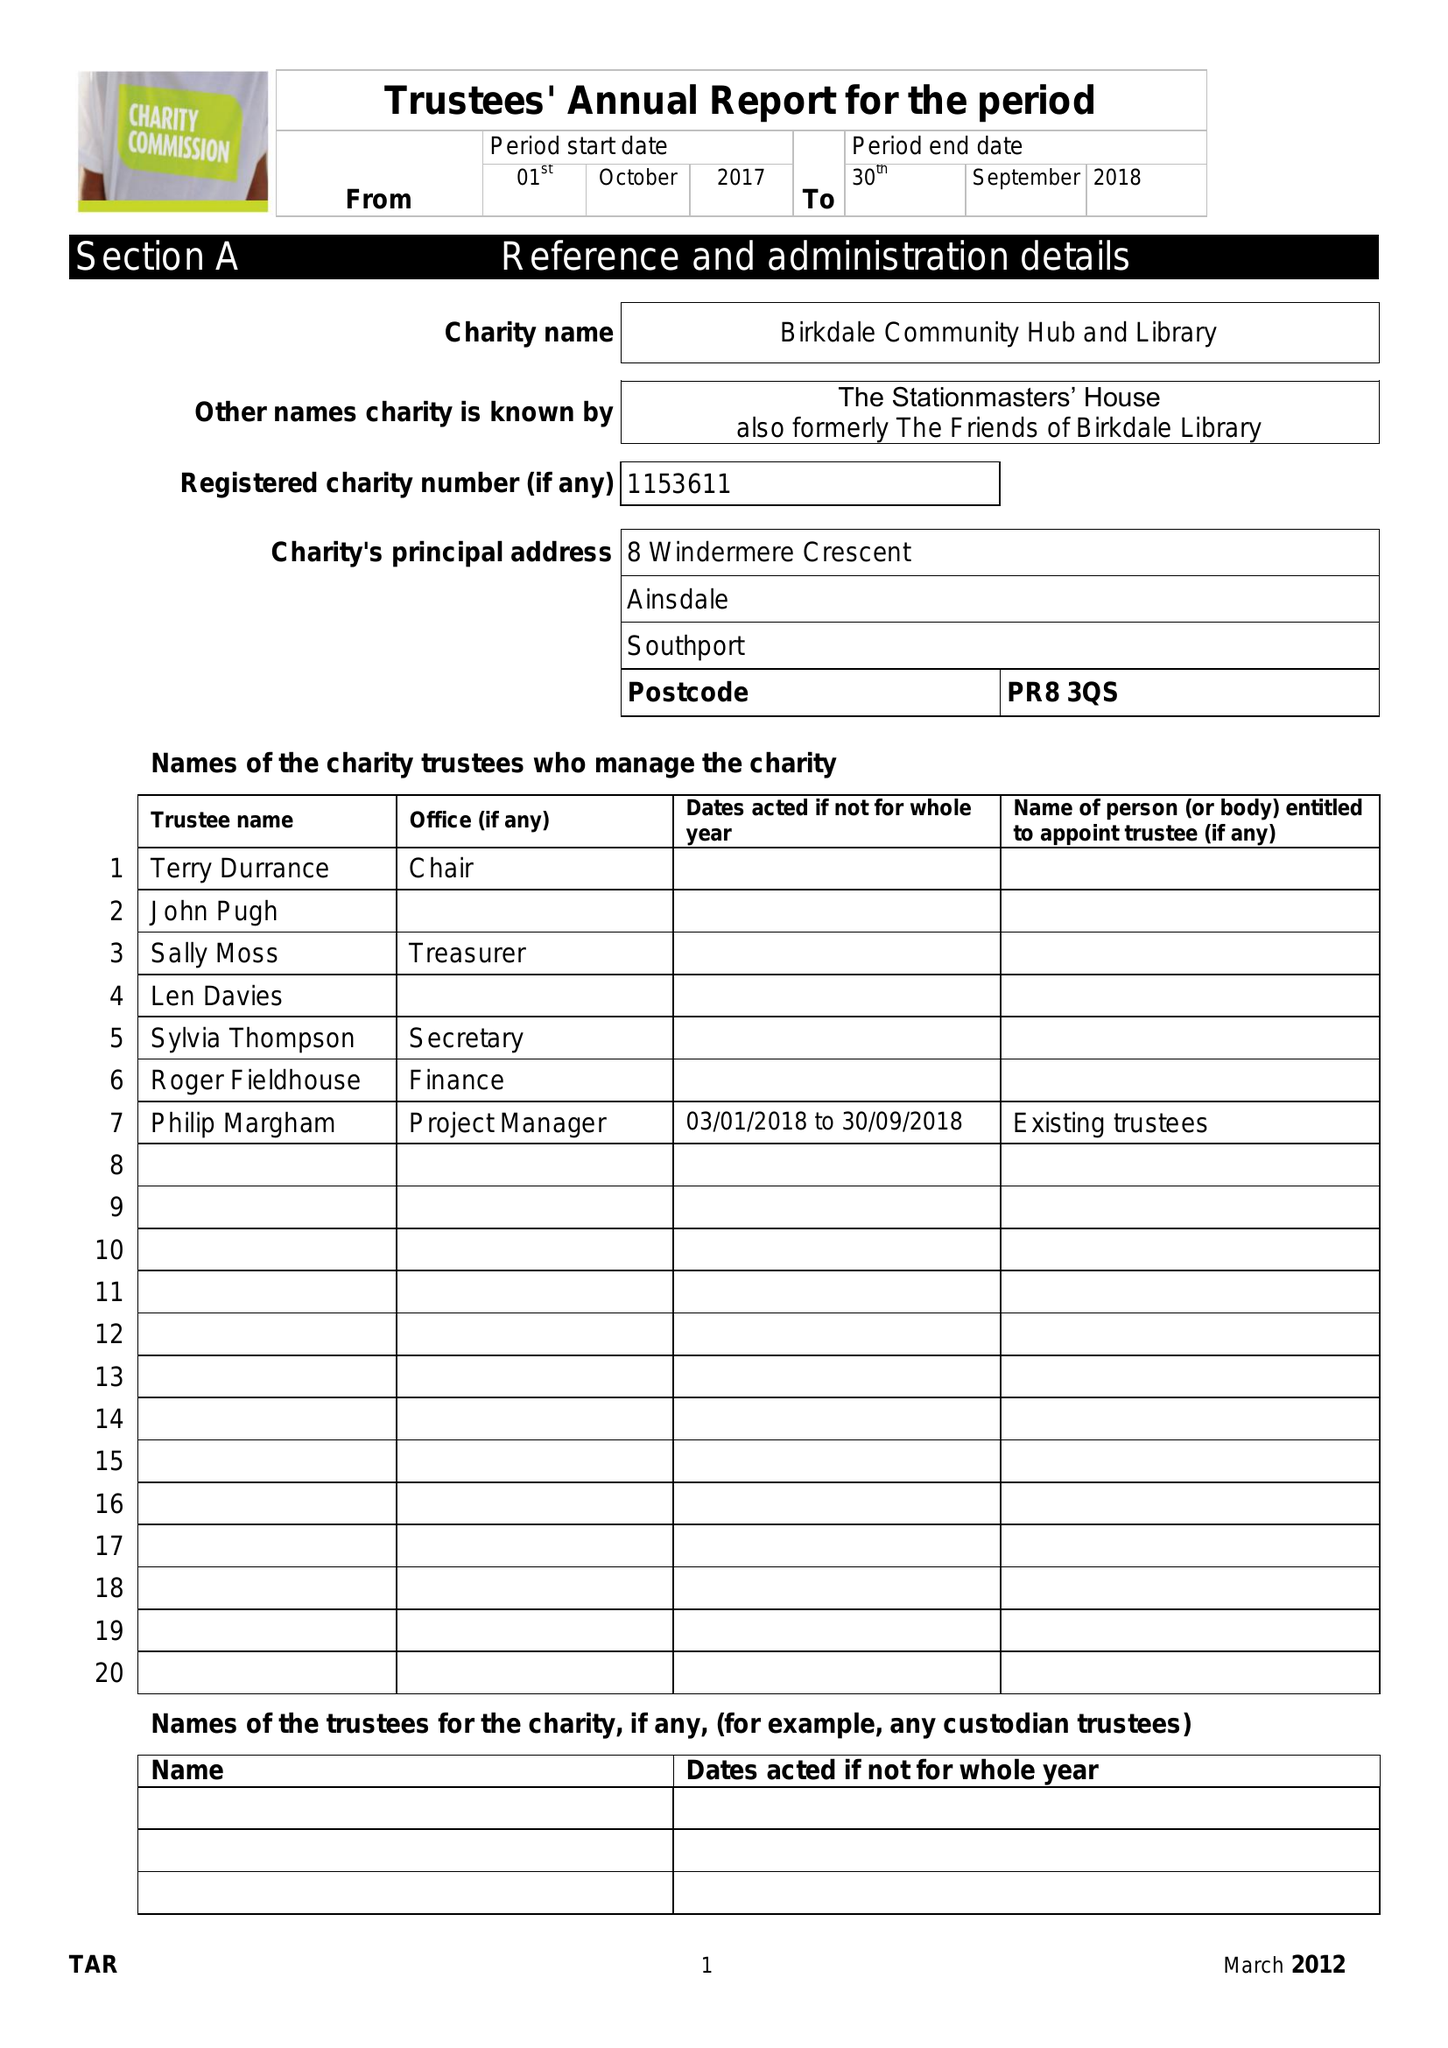What is the value for the charity_name?
Answer the question using a single word or phrase. Birkdale Community Hub and Library 